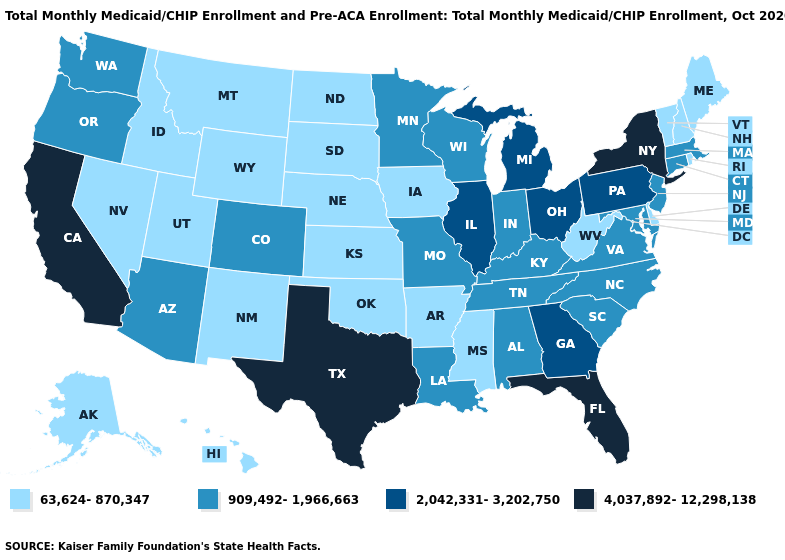Name the states that have a value in the range 4,037,892-12,298,138?
Short answer required. California, Florida, New York, Texas. Does the first symbol in the legend represent the smallest category?
Be succinct. Yes. Does New York have the same value as Illinois?
Quick response, please. No. Name the states that have a value in the range 909,492-1,966,663?
Concise answer only. Alabama, Arizona, Colorado, Connecticut, Indiana, Kentucky, Louisiana, Maryland, Massachusetts, Minnesota, Missouri, New Jersey, North Carolina, Oregon, South Carolina, Tennessee, Virginia, Washington, Wisconsin. What is the highest value in the South ?
Quick response, please. 4,037,892-12,298,138. Name the states that have a value in the range 2,042,331-3,202,750?
Concise answer only. Georgia, Illinois, Michigan, Ohio, Pennsylvania. Does South Dakota have a higher value than Virginia?
Be succinct. No. Does Georgia have a higher value than Arizona?
Quick response, please. Yes. What is the highest value in the USA?
Concise answer only. 4,037,892-12,298,138. Name the states that have a value in the range 63,624-870,347?
Keep it brief. Alaska, Arkansas, Delaware, Hawaii, Idaho, Iowa, Kansas, Maine, Mississippi, Montana, Nebraska, Nevada, New Hampshire, New Mexico, North Dakota, Oklahoma, Rhode Island, South Dakota, Utah, Vermont, West Virginia, Wyoming. What is the value of Connecticut?
Quick response, please. 909,492-1,966,663. Is the legend a continuous bar?
Give a very brief answer. No. What is the highest value in the MidWest ?
Keep it brief. 2,042,331-3,202,750. Does Wisconsin have a lower value than Virginia?
Answer briefly. No. Name the states that have a value in the range 2,042,331-3,202,750?
Be succinct. Georgia, Illinois, Michigan, Ohio, Pennsylvania. 